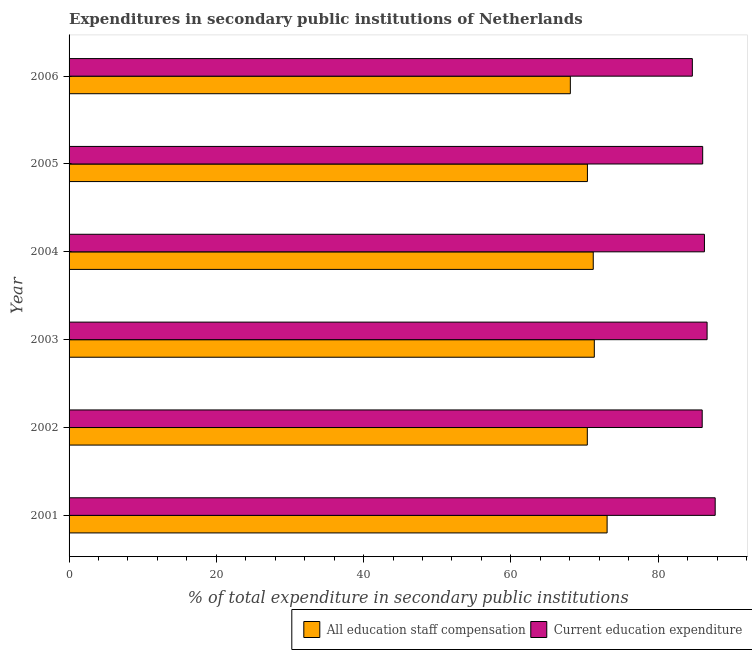How many different coloured bars are there?
Offer a very short reply. 2. How many groups of bars are there?
Offer a terse response. 6. Are the number of bars per tick equal to the number of legend labels?
Your answer should be compact. Yes. Are the number of bars on each tick of the Y-axis equal?
Your answer should be very brief. Yes. How many bars are there on the 2nd tick from the top?
Your answer should be compact. 2. What is the label of the 2nd group of bars from the top?
Offer a terse response. 2005. In how many cases, is the number of bars for a given year not equal to the number of legend labels?
Make the answer very short. 0. What is the expenditure in staff compensation in 2001?
Offer a terse response. 73.07. Across all years, what is the maximum expenditure in education?
Provide a succinct answer. 87.75. Across all years, what is the minimum expenditure in education?
Ensure brevity in your answer.  84.65. In which year was the expenditure in education maximum?
Your response must be concise. 2001. What is the total expenditure in staff compensation in the graph?
Your answer should be compact. 424.44. What is the difference between the expenditure in education in 2003 and that in 2004?
Make the answer very short. 0.36. What is the difference between the expenditure in staff compensation in 2004 and the expenditure in education in 2006?
Offer a terse response. -13.46. What is the average expenditure in education per year?
Offer a very short reply. 86.23. In the year 2002, what is the difference between the expenditure in staff compensation and expenditure in education?
Offer a terse response. -15.6. Is the expenditure in staff compensation in 2004 less than that in 2006?
Provide a short and direct response. No. What is the difference between the highest and the second highest expenditure in staff compensation?
Your response must be concise. 1.74. What is the difference between the highest and the lowest expenditure in education?
Provide a short and direct response. 3.1. In how many years, is the expenditure in staff compensation greater than the average expenditure in staff compensation taken over all years?
Make the answer very short. 3. Is the sum of the expenditure in staff compensation in 2003 and 2006 greater than the maximum expenditure in education across all years?
Offer a terse response. Yes. What does the 2nd bar from the top in 2003 represents?
Your response must be concise. All education staff compensation. What does the 2nd bar from the bottom in 2005 represents?
Make the answer very short. Current education expenditure. Does the graph contain grids?
Ensure brevity in your answer.  No. Where does the legend appear in the graph?
Offer a terse response. Bottom right. How many legend labels are there?
Keep it short and to the point. 2. How are the legend labels stacked?
Offer a very short reply. Horizontal. What is the title of the graph?
Your response must be concise. Expenditures in secondary public institutions of Netherlands. What is the label or title of the X-axis?
Ensure brevity in your answer.  % of total expenditure in secondary public institutions. What is the % of total expenditure in secondary public institutions of All education staff compensation in 2001?
Provide a short and direct response. 73.07. What is the % of total expenditure in secondary public institutions in Current education expenditure in 2001?
Provide a short and direct response. 87.75. What is the % of total expenditure in secondary public institutions of All education staff compensation in 2002?
Offer a very short reply. 70.38. What is the % of total expenditure in secondary public institutions in Current education expenditure in 2002?
Ensure brevity in your answer.  85.98. What is the % of total expenditure in secondary public institutions in All education staff compensation in 2003?
Offer a very short reply. 71.33. What is the % of total expenditure in secondary public institutions of Current education expenditure in 2003?
Provide a succinct answer. 86.65. What is the % of total expenditure in secondary public institutions in All education staff compensation in 2004?
Give a very brief answer. 71.19. What is the % of total expenditure in secondary public institutions in Current education expenditure in 2004?
Provide a short and direct response. 86.29. What is the % of total expenditure in secondary public institutions in All education staff compensation in 2005?
Provide a succinct answer. 70.4. What is the % of total expenditure in secondary public institutions in Current education expenditure in 2005?
Offer a terse response. 86.05. What is the % of total expenditure in secondary public institutions in All education staff compensation in 2006?
Your answer should be very brief. 68.08. What is the % of total expenditure in secondary public institutions in Current education expenditure in 2006?
Make the answer very short. 84.65. Across all years, what is the maximum % of total expenditure in secondary public institutions in All education staff compensation?
Keep it short and to the point. 73.07. Across all years, what is the maximum % of total expenditure in secondary public institutions of Current education expenditure?
Offer a very short reply. 87.75. Across all years, what is the minimum % of total expenditure in secondary public institutions in All education staff compensation?
Your response must be concise. 68.08. Across all years, what is the minimum % of total expenditure in secondary public institutions of Current education expenditure?
Offer a terse response. 84.65. What is the total % of total expenditure in secondary public institutions of All education staff compensation in the graph?
Offer a terse response. 424.44. What is the total % of total expenditure in secondary public institutions of Current education expenditure in the graph?
Provide a short and direct response. 517.36. What is the difference between the % of total expenditure in secondary public institutions of All education staff compensation in 2001 and that in 2002?
Give a very brief answer. 2.69. What is the difference between the % of total expenditure in secondary public institutions of Current education expenditure in 2001 and that in 2002?
Your answer should be very brief. 1.76. What is the difference between the % of total expenditure in secondary public institutions in All education staff compensation in 2001 and that in 2003?
Make the answer very short. 1.74. What is the difference between the % of total expenditure in secondary public institutions of Current education expenditure in 2001 and that in 2003?
Provide a succinct answer. 1.1. What is the difference between the % of total expenditure in secondary public institutions of All education staff compensation in 2001 and that in 2004?
Your answer should be very brief. 1.88. What is the difference between the % of total expenditure in secondary public institutions of Current education expenditure in 2001 and that in 2004?
Provide a succinct answer. 1.46. What is the difference between the % of total expenditure in secondary public institutions in All education staff compensation in 2001 and that in 2005?
Provide a short and direct response. 2.67. What is the difference between the % of total expenditure in secondary public institutions in Current education expenditure in 2001 and that in 2005?
Your response must be concise. 1.7. What is the difference between the % of total expenditure in secondary public institutions of All education staff compensation in 2001 and that in 2006?
Ensure brevity in your answer.  4.99. What is the difference between the % of total expenditure in secondary public institutions of Current education expenditure in 2001 and that in 2006?
Provide a short and direct response. 3.1. What is the difference between the % of total expenditure in secondary public institutions of All education staff compensation in 2002 and that in 2003?
Keep it short and to the point. -0.95. What is the difference between the % of total expenditure in secondary public institutions of Current education expenditure in 2002 and that in 2003?
Make the answer very short. -0.66. What is the difference between the % of total expenditure in secondary public institutions of All education staff compensation in 2002 and that in 2004?
Give a very brief answer. -0.81. What is the difference between the % of total expenditure in secondary public institutions of Current education expenditure in 2002 and that in 2004?
Offer a terse response. -0.31. What is the difference between the % of total expenditure in secondary public institutions in All education staff compensation in 2002 and that in 2005?
Your answer should be compact. -0.02. What is the difference between the % of total expenditure in secondary public institutions in Current education expenditure in 2002 and that in 2005?
Your response must be concise. -0.07. What is the difference between the % of total expenditure in secondary public institutions in All education staff compensation in 2002 and that in 2006?
Provide a short and direct response. 2.3. What is the difference between the % of total expenditure in secondary public institutions in Current education expenditure in 2002 and that in 2006?
Make the answer very short. 1.34. What is the difference between the % of total expenditure in secondary public institutions of All education staff compensation in 2003 and that in 2004?
Your answer should be very brief. 0.14. What is the difference between the % of total expenditure in secondary public institutions in Current education expenditure in 2003 and that in 2004?
Keep it short and to the point. 0.36. What is the difference between the % of total expenditure in secondary public institutions of All education staff compensation in 2003 and that in 2005?
Your answer should be very brief. 0.94. What is the difference between the % of total expenditure in secondary public institutions of Current education expenditure in 2003 and that in 2005?
Keep it short and to the point. 0.6. What is the difference between the % of total expenditure in secondary public institutions of All education staff compensation in 2003 and that in 2006?
Ensure brevity in your answer.  3.26. What is the difference between the % of total expenditure in secondary public institutions of Current education expenditure in 2003 and that in 2006?
Keep it short and to the point. 2. What is the difference between the % of total expenditure in secondary public institutions of All education staff compensation in 2004 and that in 2005?
Your answer should be very brief. 0.79. What is the difference between the % of total expenditure in secondary public institutions of Current education expenditure in 2004 and that in 2005?
Give a very brief answer. 0.24. What is the difference between the % of total expenditure in secondary public institutions in All education staff compensation in 2004 and that in 2006?
Provide a short and direct response. 3.11. What is the difference between the % of total expenditure in secondary public institutions of Current education expenditure in 2004 and that in 2006?
Your answer should be compact. 1.64. What is the difference between the % of total expenditure in secondary public institutions of All education staff compensation in 2005 and that in 2006?
Keep it short and to the point. 2.32. What is the difference between the % of total expenditure in secondary public institutions of Current education expenditure in 2005 and that in 2006?
Keep it short and to the point. 1.4. What is the difference between the % of total expenditure in secondary public institutions of All education staff compensation in 2001 and the % of total expenditure in secondary public institutions of Current education expenditure in 2002?
Keep it short and to the point. -12.91. What is the difference between the % of total expenditure in secondary public institutions of All education staff compensation in 2001 and the % of total expenditure in secondary public institutions of Current education expenditure in 2003?
Keep it short and to the point. -13.58. What is the difference between the % of total expenditure in secondary public institutions of All education staff compensation in 2001 and the % of total expenditure in secondary public institutions of Current education expenditure in 2004?
Your answer should be very brief. -13.22. What is the difference between the % of total expenditure in secondary public institutions in All education staff compensation in 2001 and the % of total expenditure in secondary public institutions in Current education expenditure in 2005?
Keep it short and to the point. -12.98. What is the difference between the % of total expenditure in secondary public institutions of All education staff compensation in 2001 and the % of total expenditure in secondary public institutions of Current education expenditure in 2006?
Provide a succinct answer. -11.58. What is the difference between the % of total expenditure in secondary public institutions of All education staff compensation in 2002 and the % of total expenditure in secondary public institutions of Current education expenditure in 2003?
Give a very brief answer. -16.27. What is the difference between the % of total expenditure in secondary public institutions of All education staff compensation in 2002 and the % of total expenditure in secondary public institutions of Current education expenditure in 2004?
Ensure brevity in your answer.  -15.91. What is the difference between the % of total expenditure in secondary public institutions of All education staff compensation in 2002 and the % of total expenditure in secondary public institutions of Current education expenditure in 2005?
Your response must be concise. -15.67. What is the difference between the % of total expenditure in secondary public institutions in All education staff compensation in 2002 and the % of total expenditure in secondary public institutions in Current education expenditure in 2006?
Make the answer very short. -14.27. What is the difference between the % of total expenditure in secondary public institutions in All education staff compensation in 2003 and the % of total expenditure in secondary public institutions in Current education expenditure in 2004?
Provide a succinct answer. -14.96. What is the difference between the % of total expenditure in secondary public institutions of All education staff compensation in 2003 and the % of total expenditure in secondary public institutions of Current education expenditure in 2005?
Keep it short and to the point. -14.72. What is the difference between the % of total expenditure in secondary public institutions of All education staff compensation in 2003 and the % of total expenditure in secondary public institutions of Current education expenditure in 2006?
Provide a short and direct response. -13.31. What is the difference between the % of total expenditure in secondary public institutions of All education staff compensation in 2004 and the % of total expenditure in secondary public institutions of Current education expenditure in 2005?
Your response must be concise. -14.86. What is the difference between the % of total expenditure in secondary public institutions in All education staff compensation in 2004 and the % of total expenditure in secondary public institutions in Current education expenditure in 2006?
Your answer should be very brief. -13.46. What is the difference between the % of total expenditure in secondary public institutions in All education staff compensation in 2005 and the % of total expenditure in secondary public institutions in Current education expenditure in 2006?
Make the answer very short. -14.25. What is the average % of total expenditure in secondary public institutions of All education staff compensation per year?
Keep it short and to the point. 70.74. What is the average % of total expenditure in secondary public institutions of Current education expenditure per year?
Your answer should be compact. 86.23. In the year 2001, what is the difference between the % of total expenditure in secondary public institutions of All education staff compensation and % of total expenditure in secondary public institutions of Current education expenditure?
Provide a succinct answer. -14.68. In the year 2002, what is the difference between the % of total expenditure in secondary public institutions in All education staff compensation and % of total expenditure in secondary public institutions in Current education expenditure?
Your response must be concise. -15.6. In the year 2003, what is the difference between the % of total expenditure in secondary public institutions of All education staff compensation and % of total expenditure in secondary public institutions of Current education expenditure?
Offer a terse response. -15.31. In the year 2004, what is the difference between the % of total expenditure in secondary public institutions in All education staff compensation and % of total expenditure in secondary public institutions in Current education expenditure?
Your response must be concise. -15.1. In the year 2005, what is the difference between the % of total expenditure in secondary public institutions in All education staff compensation and % of total expenditure in secondary public institutions in Current education expenditure?
Your response must be concise. -15.65. In the year 2006, what is the difference between the % of total expenditure in secondary public institutions of All education staff compensation and % of total expenditure in secondary public institutions of Current education expenditure?
Offer a very short reply. -16.57. What is the ratio of the % of total expenditure in secondary public institutions of All education staff compensation in 2001 to that in 2002?
Provide a succinct answer. 1.04. What is the ratio of the % of total expenditure in secondary public institutions of Current education expenditure in 2001 to that in 2002?
Ensure brevity in your answer.  1.02. What is the ratio of the % of total expenditure in secondary public institutions in All education staff compensation in 2001 to that in 2003?
Provide a short and direct response. 1.02. What is the ratio of the % of total expenditure in secondary public institutions of Current education expenditure in 2001 to that in 2003?
Your answer should be compact. 1.01. What is the ratio of the % of total expenditure in secondary public institutions of All education staff compensation in 2001 to that in 2004?
Provide a short and direct response. 1.03. What is the ratio of the % of total expenditure in secondary public institutions of Current education expenditure in 2001 to that in 2004?
Make the answer very short. 1.02. What is the ratio of the % of total expenditure in secondary public institutions of All education staff compensation in 2001 to that in 2005?
Keep it short and to the point. 1.04. What is the ratio of the % of total expenditure in secondary public institutions in Current education expenditure in 2001 to that in 2005?
Your response must be concise. 1.02. What is the ratio of the % of total expenditure in secondary public institutions of All education staff compensation in 2001 to that in 2006?
Provide a succinct answer. 1.07. What is the ratio of the % of total expenditure in secondary public institutions of Current education expenditure in 2001 to that in 2006?
Your answer should be compact. 1.04. What is the ratio of the % of total expenditure in secondary public institutions of All education staff compensation in 2002 to that in 2003?
Offer a terse response. 0.99. What is the ratio of the % of total expenditure in secondary public institutions of Current education expenditure in 2002 to that in 2003?
Your response must be concise. 0.99. What is the ratio of the % of total expenditure in secondary public institutions in All education staff compensation in 2002 to that in 2004?
Keep it short and to the point. 0.99. What is the ratio of the % of total expenditure in secondary public institutions of All education staff compensation in 2002 to that in 2005?
Offer a very short reply. 1. What is the ratio of the % of total expenditure in secondary public institutions in All education staff compensation in 2002 to that in 2006?
Give a very brief answer. 1.03. What is the ratio of the % of total expenditure in secondary public institutions in Current education expenditure in 2002 to that in 2006?
Keep it short and to the point. 1.02. What is the ratio of the % of total expenditure in secondary public institutions of All education staff compensation in 2003 to that in 2005?
Your answer should be compact. 1.01. What is the ratio of the % of total expenditure in secondary public institutions in Current education expenditure in 2003 to that in 2005?
Ensure brevity in your answer.  1.01. What is the ratio of the % of total expenditure in secondary public institutions in All education staff compensation in 2003 to that in 2006?
Offer a very short reply. 1.05. What is the ratio of the % of total expenditure in secondary public institutions in Current education expenditure in 2003 to that in 2006?
Provide a short and direct response. 1.02. What is the ratio of the % of total expenditure in secondary public institutions in All education staff compensation in 2004 to that in 2005?
Make the answer very short. 1.01. What is the ratio of the % of total expenditure in secondary public institutions of All education staff compensation in 2004 to that in 2006?
Make the answer very short. 1.05. What is the ratio of the % of total expenditure in secondary public institutions of Current education expenditure in 2004 to that in 2006?
Your answer should be compact. 1.02. What is the ratio of the % of total expenditure in secondary public institutions in All education staff compensation in 2005 to that in 2006?
Your answer should be compact. 1.03. What is the ratio of the % of total expenditure in secondary public institutions in Current education expenditure in 2005 to that in 2006?
Your answer should be very brief. 1.02. What is the difference between the highest and the second highest % of total expenditure in secondary public institutions of All education staff compensation?
Your response must be concise. 1.74. What is the difference between the highest and the second highest % of total expenditure in secondary public institutions in Current education expenditure?
Give a very brief answer. 1.1. What is the difference between the highest and the lowest % of total expenditure in secondary public institutions in All education staff compensation?
Keep it short and to the point. 4.99. What is the difference between the highest and the lowest % of total expenditure in secondary public institutions of Current education expenditure?
Keep it short and to the point. 3.1. 